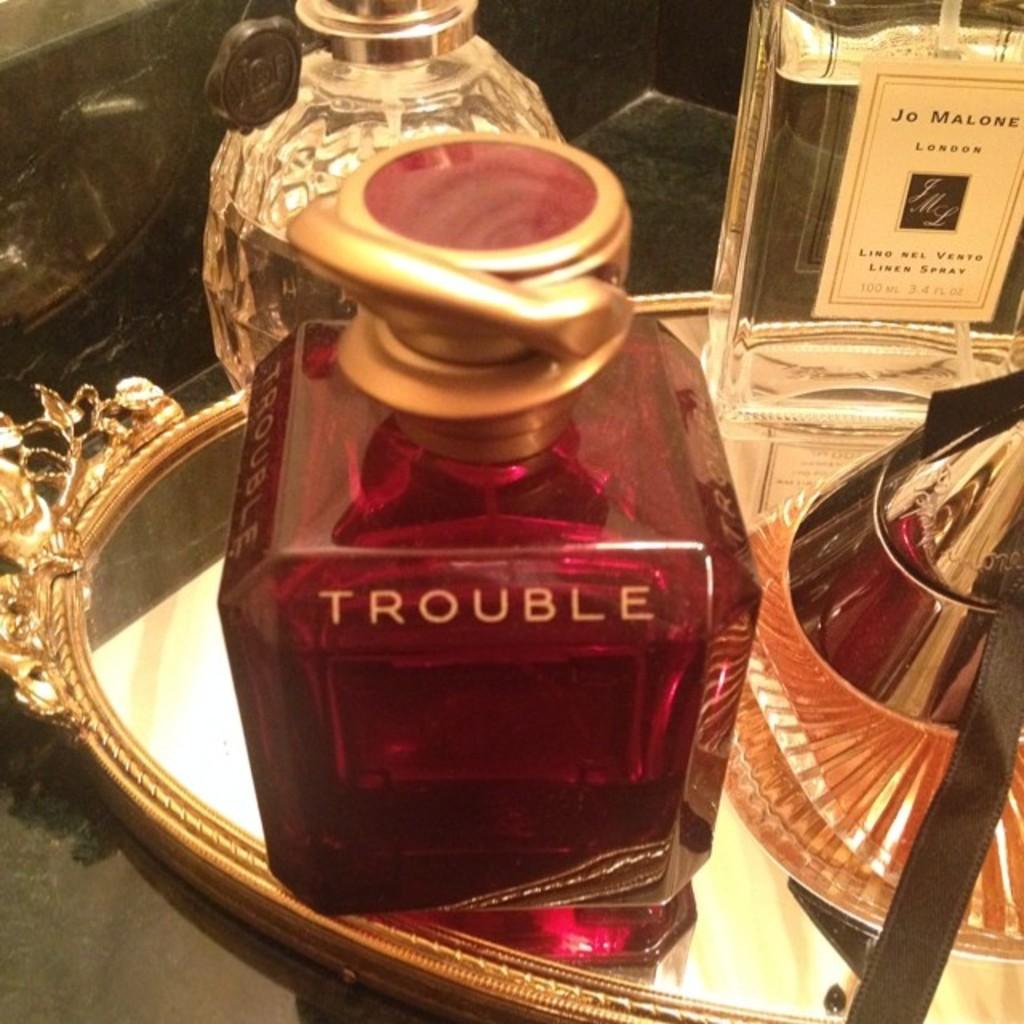What's the name of the perfume?
Make the answer very short. Trouble. What is the name on the clear bottle?
Offer a very short reply. Trouble. 